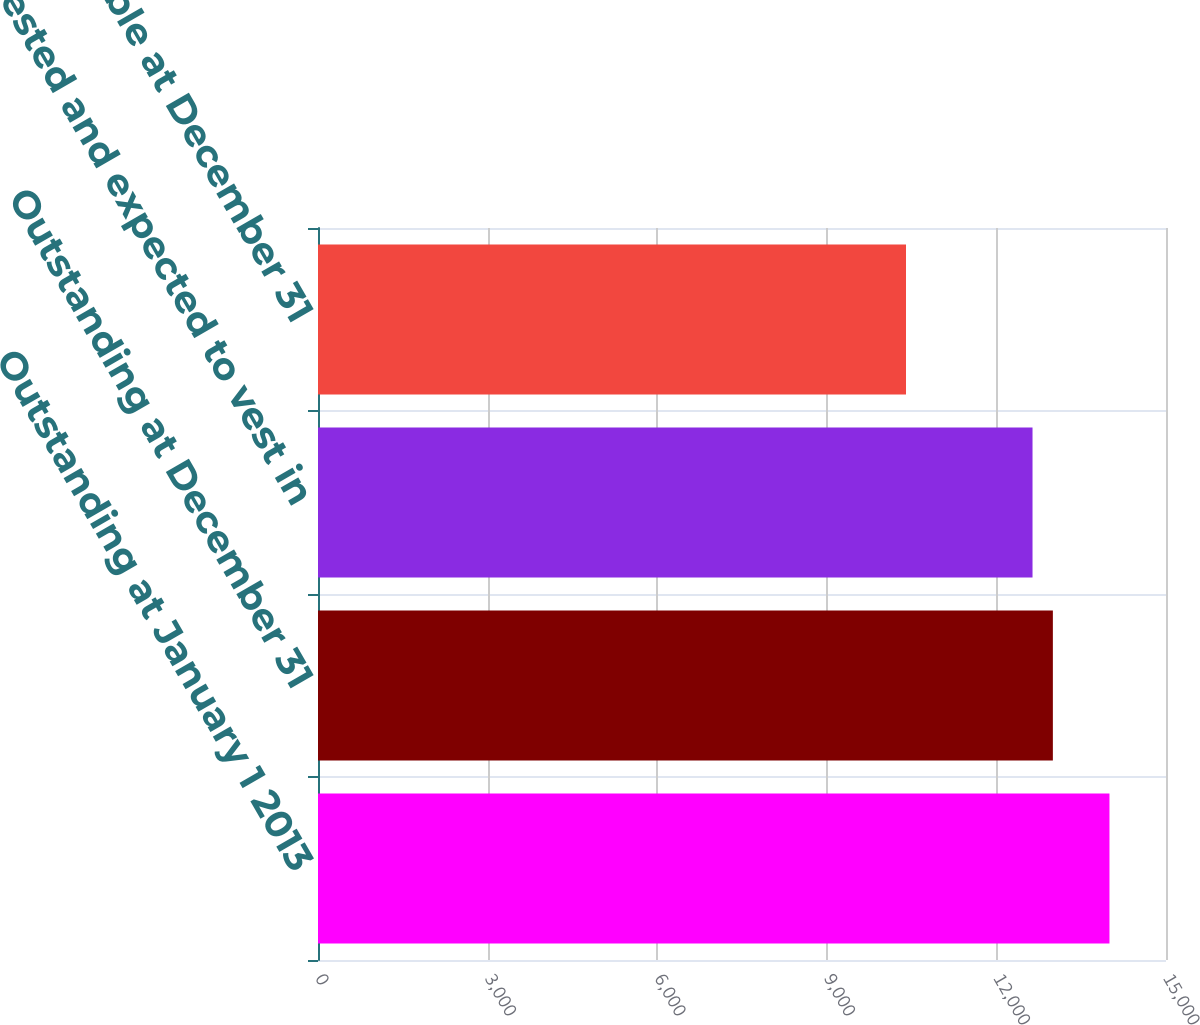Convert chart to OTSL. <chart><loc_0><loc_0><loc_500><loc_500><bar_chart><fcel>Outstanding at January 1 2013<fcel>Outstanding at December 31<fcel>Vested and expected to vest in<fcel>Exercisable at December 31<nl><fcel>14000<fcel>12998.9<fcel>12639<fcel>10401<nl></chart> 